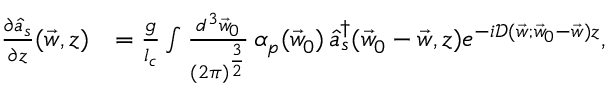<formula> <loc_0><loc_0><loc_500><loc_500>\begin{array} { r l } { \frac { \partial \hat { a } _ { s } } { \partial z } ( \vec { w } , z ) } & { = \frac { g } { l _ { c } } \int \frac { d ^ { 3 } \vec { w } _ { 0 } } { ( 2 \pi ) ^ { \frac { 3 } { 2 } } } \, { \alpha } _ { p } ( \vec { w } _ { 0 } ) \, \hat { a } _ { s } ^ { \dagger } ( \vec { w } _ { 0 } - \vec { w } , z ) e ^ { - i \mathcal { D } ( \vec { w } ; \vec { w } _ { 0 } - \vec { w } ) z } , } \end{array}</formula> 